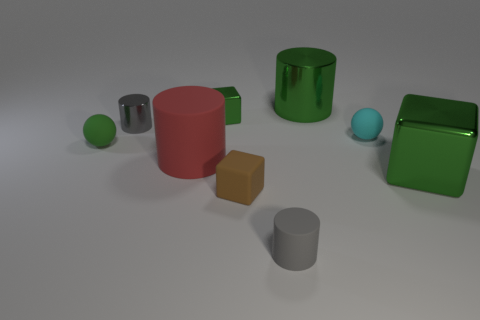How many small green things are there?
Your answer should be compact. 2. Is there any other thing that has the same size as the gray rubber object?
Offer a very short reply. Yes. Are the small brown cube and the cyan sphere made of the same material?
Your response must be concise. Yes. There is a matte cylinder in front of the large red thing; is it the same size as the metallic cylinder that is on the left side of the large green metal cylinder?
Give a very brief answer. Yes. Are there fewer large green cylinders than small metal objects?
Your answer should be very brief. Yes. How many metallic things are either tiny cyan objects or small green spheres?
Offer a terse response. 0. Is there a big green shiny cube that is to the right of the metal cube that is to the right of the small cyan rubber object?
Offer a terse response. No. Does the tiny cylinder that is behind the cyan matte sphere have the same material as the cyan ball?
Your answer should be very brief. No. What number of other things are there of the same color as the big metallic cylinder?
Make the answer very short. 3. Is the small metal cylinder the same color as the large metal cube?
Make the answer very short. No. 